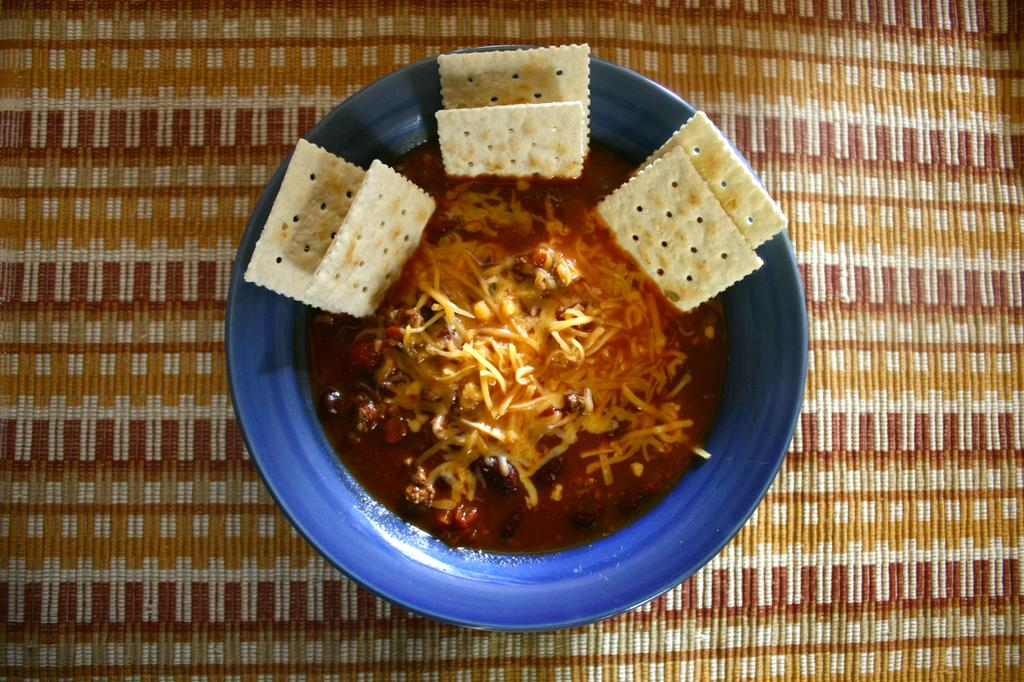What color is the bowl in the image? The bowl in the image is blue. What is inside the bowl? The bowl contains a food item. On what surface is the bowl placed? The bowl is placed on a mat surface. Is there a collar visible on the food item in the image? No, there is no collar present in the image, and the food item is not an animal that would wear a collar. 